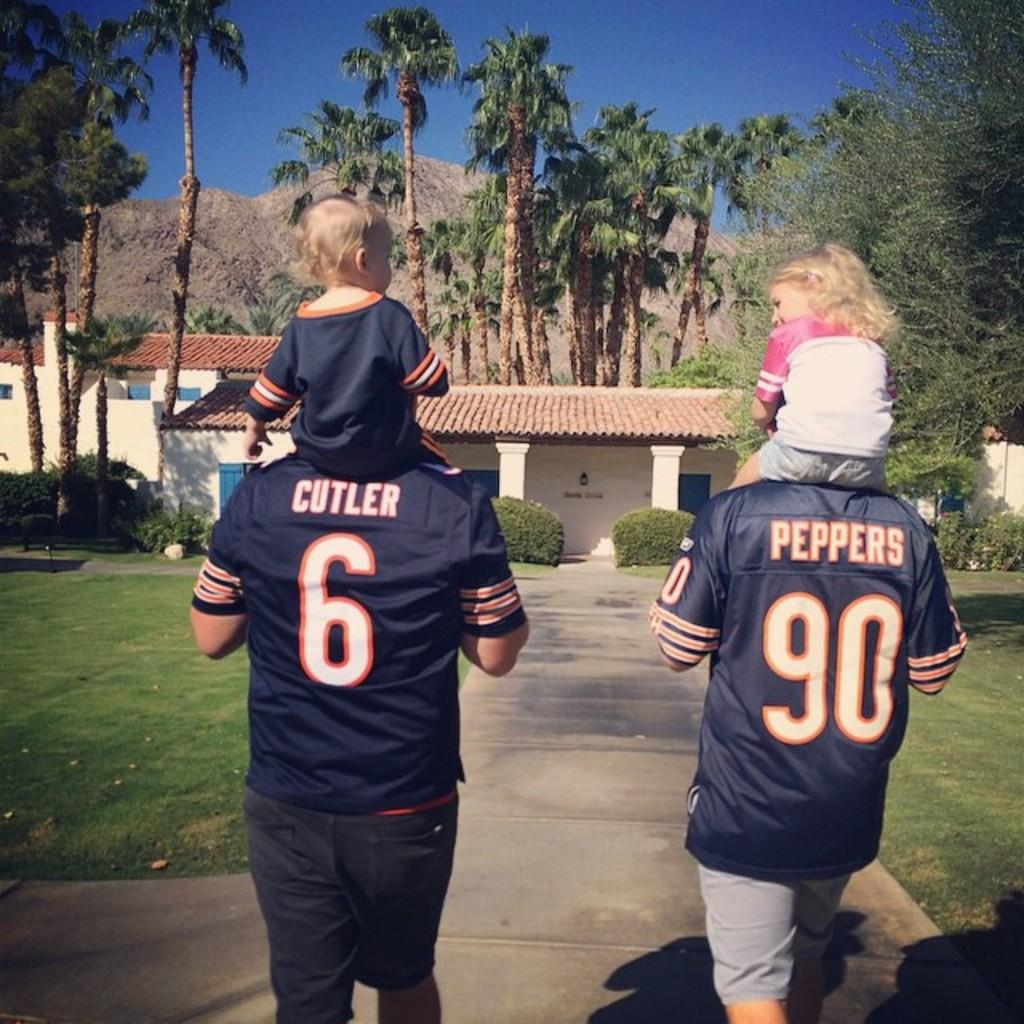<image>
Write a terse but informative summary of the picture. Two persons wearing blue jerseys one reading pepper and the other reading Cutler, walk towards a house. 